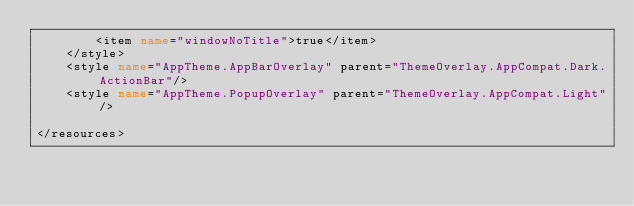Convert code to text. <code><loc_0><loc_0><loc_500><loc_500><_XML_>        <item name="windowNoTitle">true</item>
    </style>
    <style name="AppTheme.AppBarOverlay" parent="ThemeOverlay.AppCompat.Dark.ActionBar"/>
    <style name="AppTheme.PopupOverlay" parent="ThemeOverlay.AppCompat.Light"/>

</resources>
</code> 